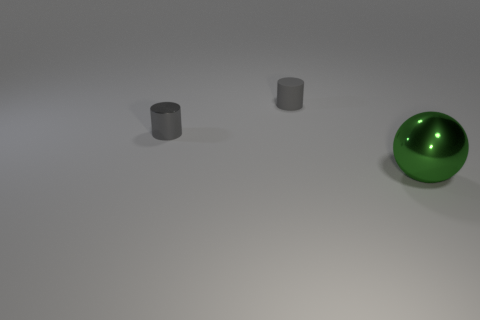Considering the positions of the objects, what sort of arrangement do they have? The objects are spaced apart from each other on a flat surface, with no apparent pattern or order. Their random placement may suggest an informal setting or a prelude to an activity. The negative space around them is ample, which puts each object in clear focus individually. Could this be a setup for an experiment or a demonstration? It's possible. The isolation and clarity of the objects against the plain background might indicate a controlled environment, suitable for a scientific experiment or demonstration to observe properties such as material, light reflection, or geometrical shape. 